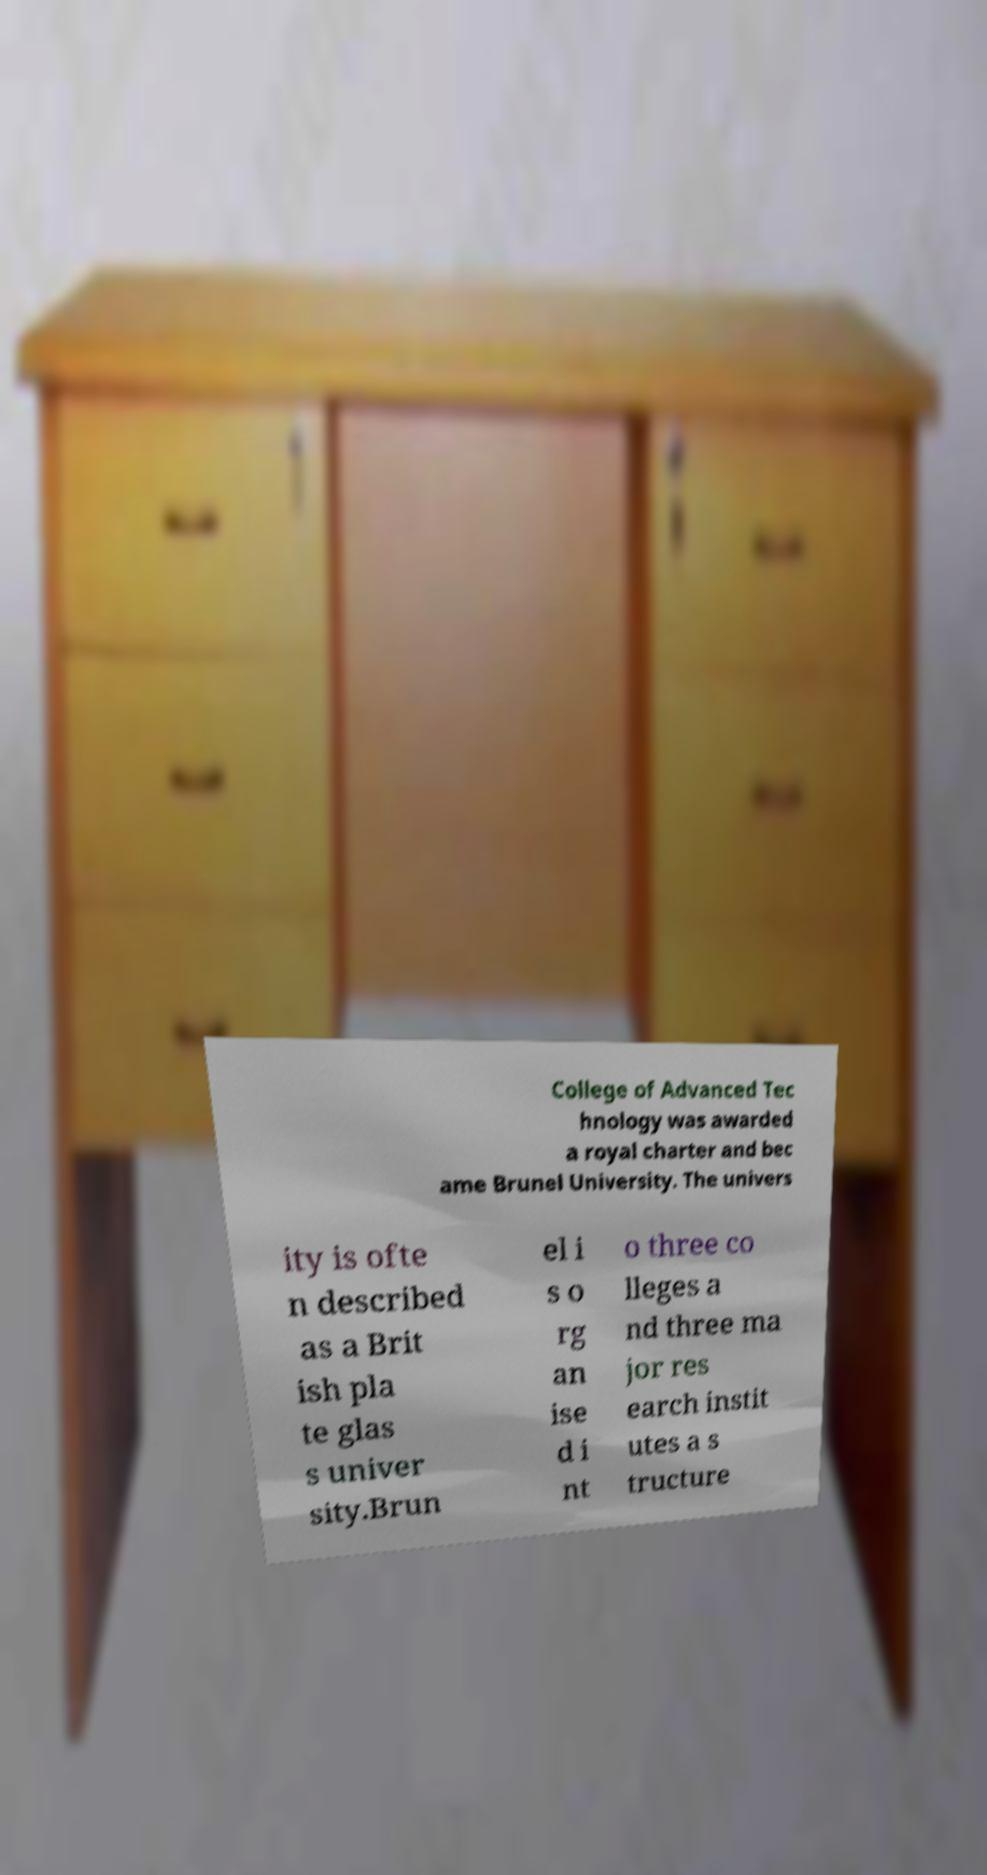There's text embedded in this image that I need extracted. Can you transcribe it verbatim? College of Advanced Tec hnology was awarded a royal charter and bec ame Brunel University. The univers ity is ofte n described as a Brit ish pla te glas s univer sity.Brun el i s o rg an ise d i nt o three co lleges a nd three ma jor res earch instit utes a s tructure 